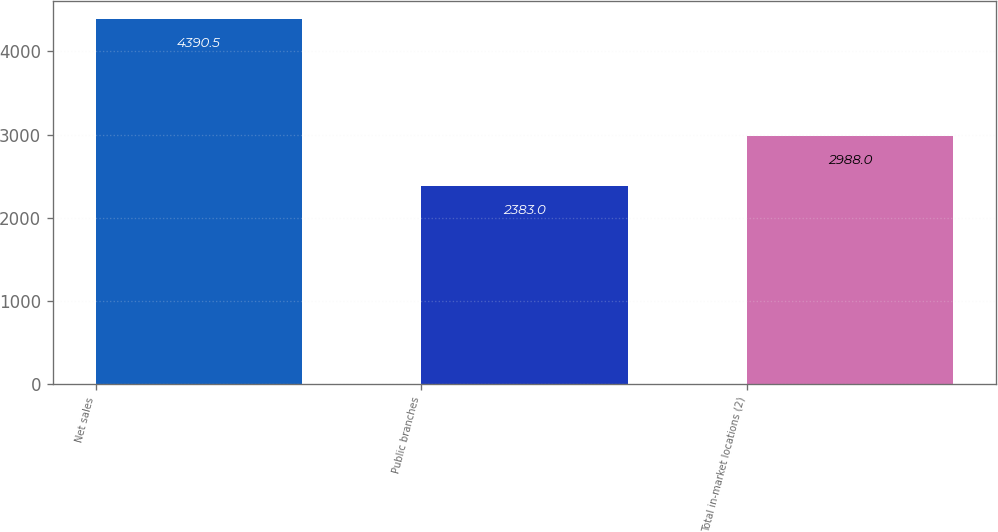Convert chart. <chart><loc_0><loc_0><loc_500><loc_500><bar_chart><fcel>Net sales<fcel>Public branches<fcel>Total in-market locations (2)<nl><fcel>4390.5<fcel>2383<fcel>2988<nl></chart> 